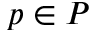<formula> <loc_0><loc_0><loc_500><loc_500>p \in P</formula> 